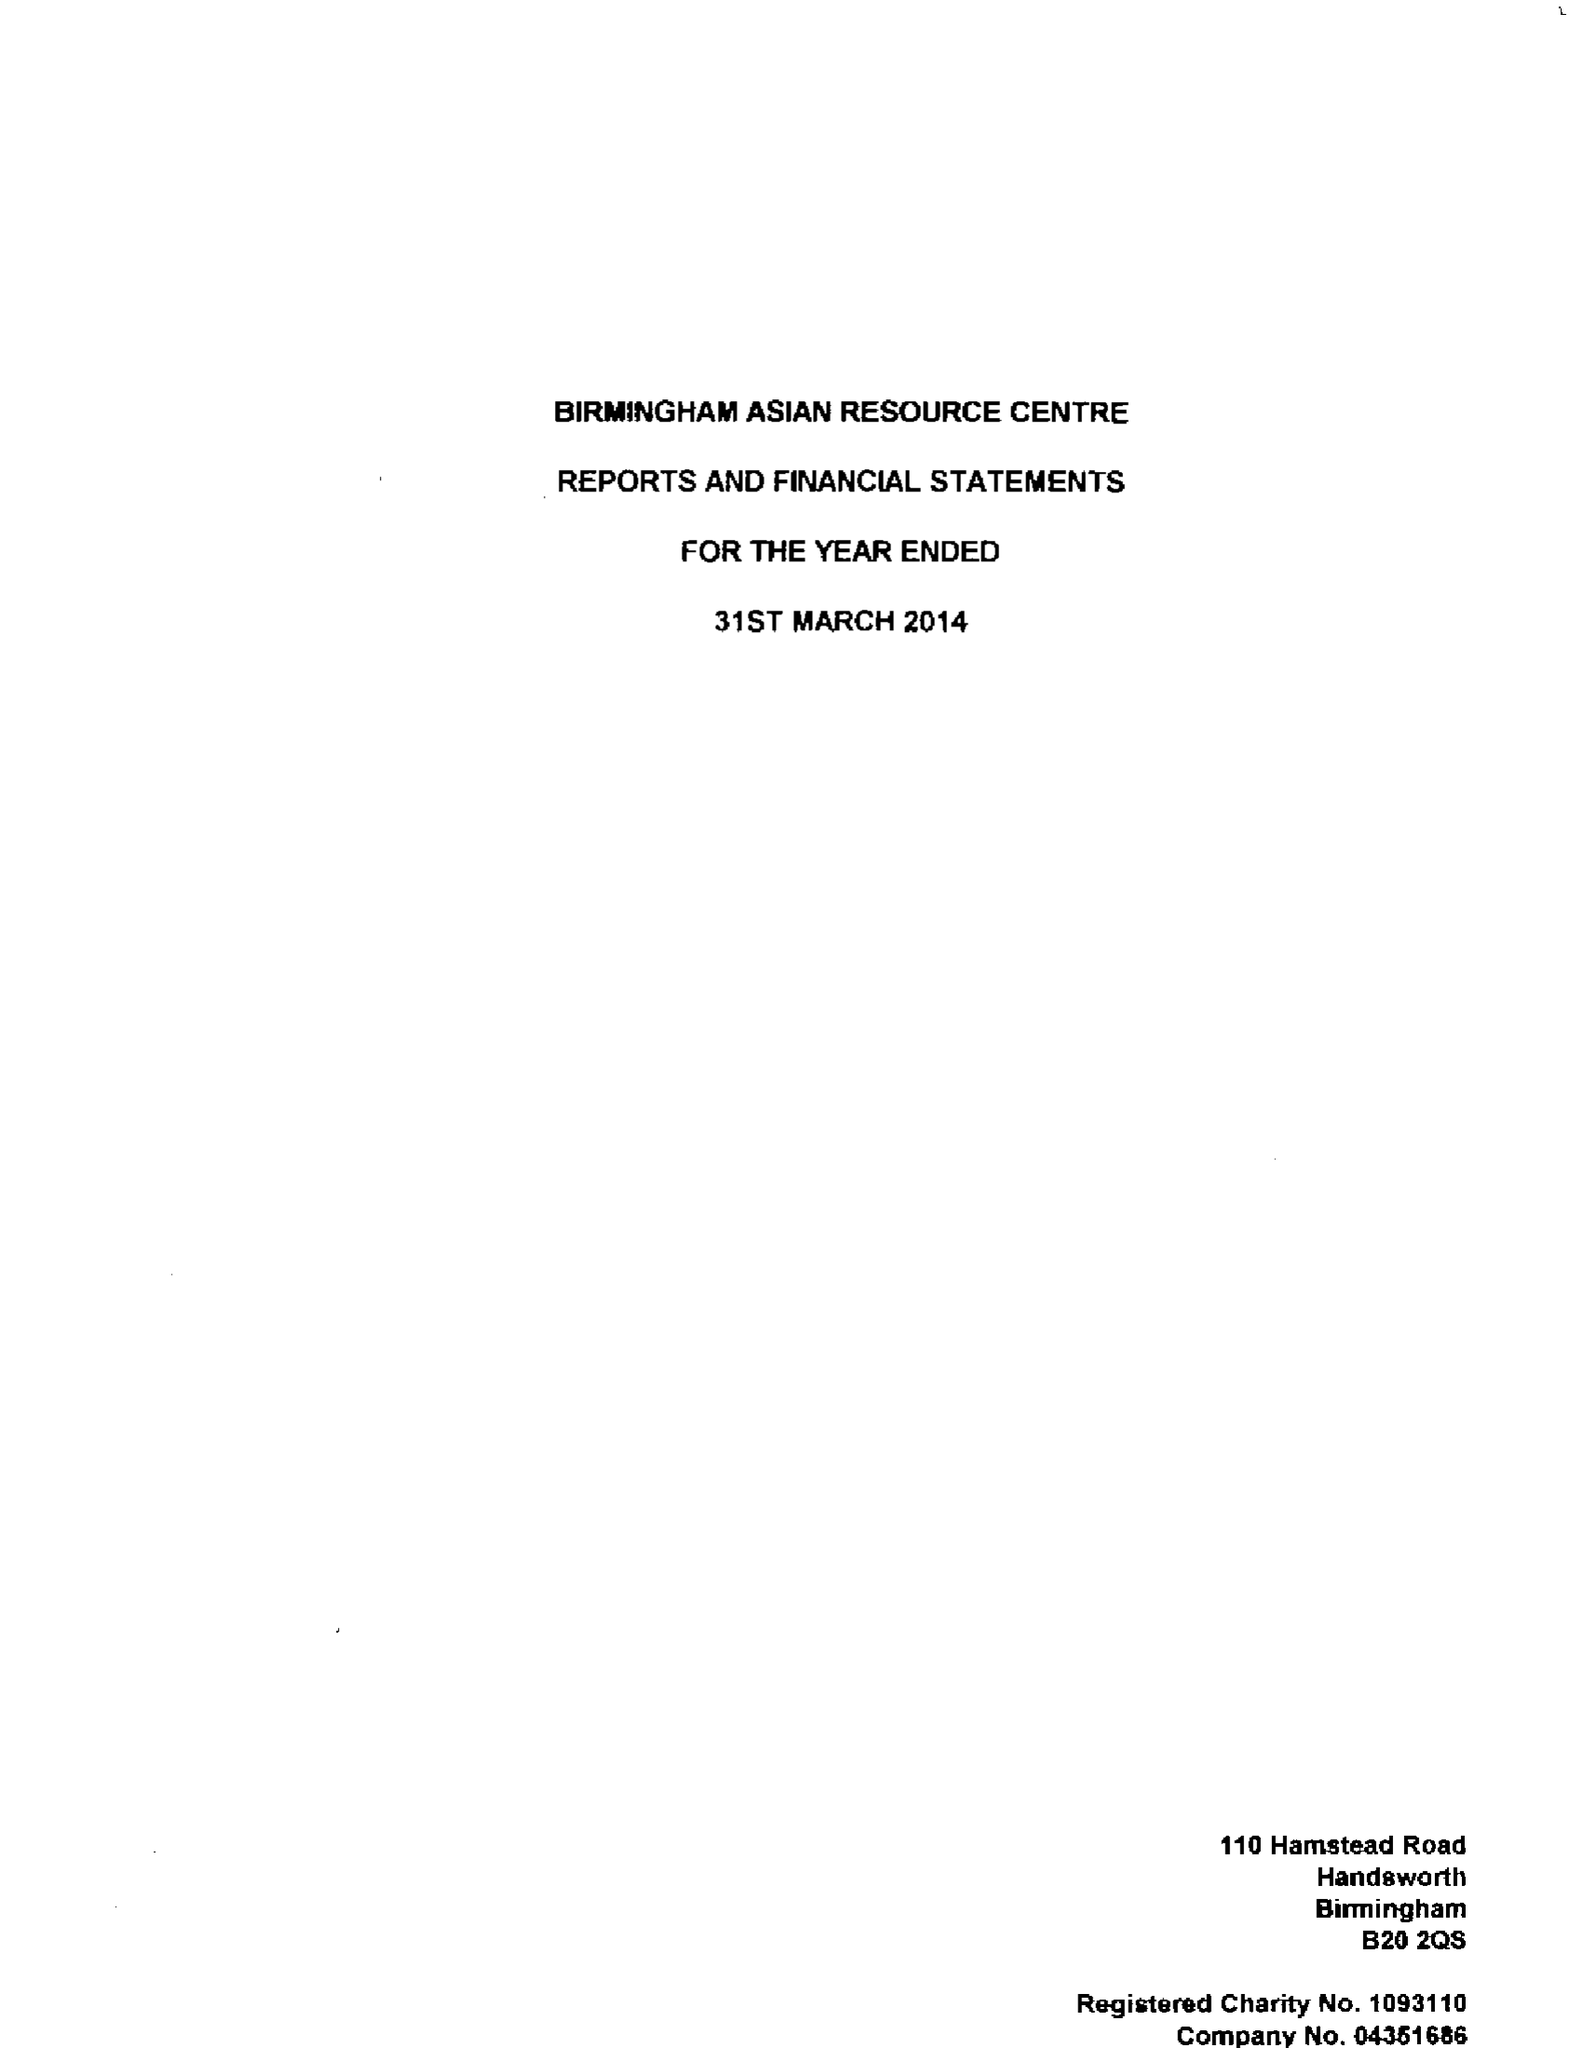What is the value for the report_date?
Answer the question using a single word or phrase. 2014-03-31 